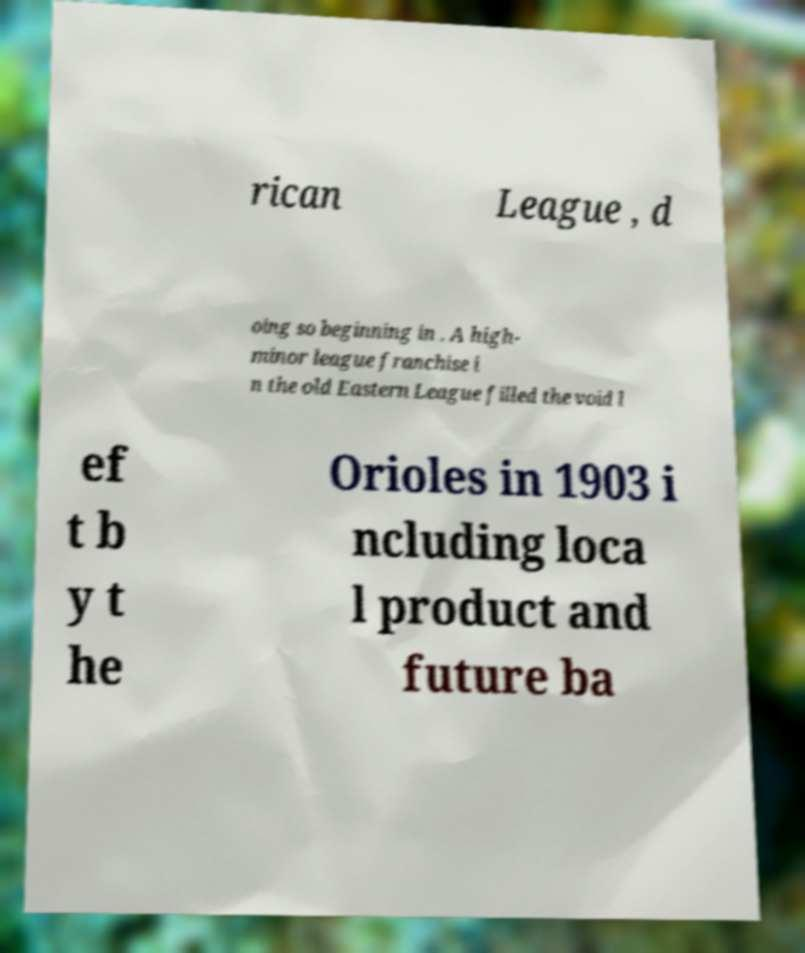Could you assist in decoding the text presented in this image and type it out clearly? rican League , d oing so beginning in . A high- minor league franchise i n the old Eastern League filled the void l ef t b y t he Orioles in 1903 i ncluding loca l product and future ba 